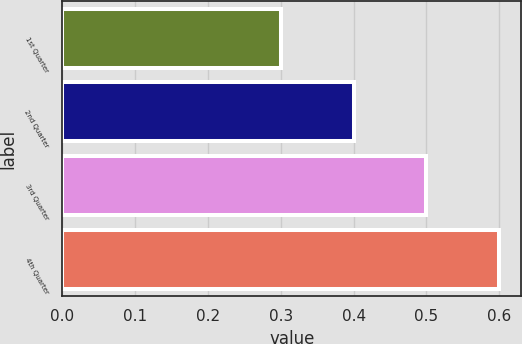Convert chart to OTSL. <chart><loc_0><loc_0><loc_500><loc_500><bar_chart><fcel>1st Quarter<fcel>2nd Quarter<fcel>3rd Quarter<fcel>4th Quarter<nl><fcel>0.3<fcel>0.4<fcel>0.5<fcel>0.6<nl></chart> 